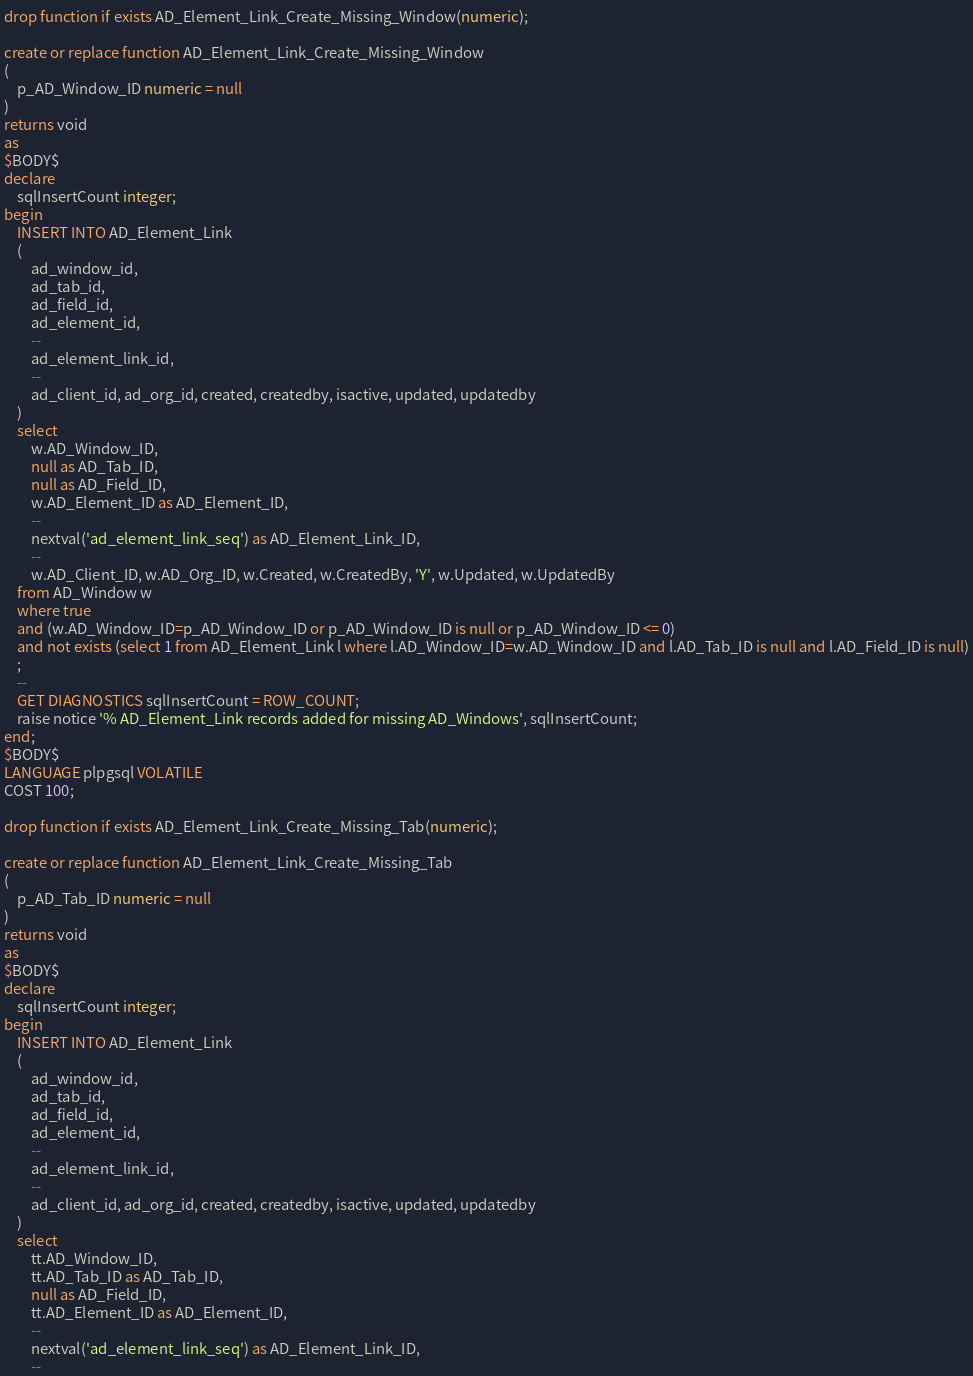<code> <loc_0><loc_0><loc_500><loc_500><_SQL_>drop function if exists AD_Element_Link_Create_Missing_Window(numeric);

create or replace function AD_Element_Link_Create_Missing_Window
(
    p_AD_Window_ID numeric = null
)
returns void
as
$BODY$ 
declare
    sqlInsertCount integer;
begin
    INSERT INTO AD_Element_Link
    (
        ad_window_id, 
        ad_tab_id, 
        ad_field_id,
        ad_element_id, 
        --
        ad_element_link_id, 
        --
        ad_client_id, ad_org_id, created, createdby, isactive, updated, updatedby
    )
    select
        w.AD_Window_ID,
        null as AD_Tab_ID,
        null as AD_Field_ID,
        w.AD_Element_ID as AD_Element_ID,
        --
        nextval('ad_element_link_seq') as AD_Element_Link_ID,
        --
        w.AD_Client_ID, w.AD_Org_ID, w.Created, w.CreatedBy, 'Y', w.Updated, w.UpdatedBy
    from AD_Window w
    where true
    and (w.AD_Window_ID=p_AD_Window_ID or p_AD_Window_ID is null or p_AD_Window_ID <= 0)
    and not exists (select 1 from AD_Element_Link l where l.AD_Window_ID=w.AD_Window_ID and l.AD_Tab_ID is null and l.AD_Field_ID is null)
    ;
    --
    GET DIAGNOSTICS sqlInsertCount = ROW_COUNT;
    raise notice '% AD_Element_Link records added for missing AD_Windows', sqlInsertCount;
end;
$BODY$
LANGUAGE plpgsql VOLATILE
COST 100;

drop function if exists AD_Element_Link_Create_Missing_Tab(numeric);

create or replace function AD_Element_Link_Create_Missing_Tab
(
    p_AD_Tab_ID numeric = null
)
returns void
as
$BODY$ 
declare
    sqlInsertCount integer;
begin
    INSERT INTO AD_Element_Link
    (
        ad_window_id, 
        ad_tab_id, 
        ad_field_id,
        ad_element_id, 
        --
        ad_element_link_id, 
        --
        ad_client_id, ad_org_id, created, createdby, isactive, updated, updatedby
    )
    select
        tt.AD_Window_ID,
        tt.AD_Tab_ID as AD_Tab_ID,
        null as AD_Field_ID,
        tt.AD_Element_ID as AD_Element_ID,
        --
        nextval('ad_element_link_seq') as AD_Element_Link_ID,
        --</code> 